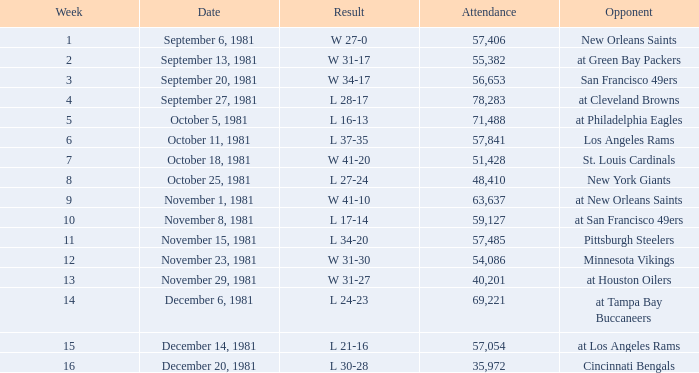What was the highest number of attendance in a week before 8 and game on October 25, 1981? None. 